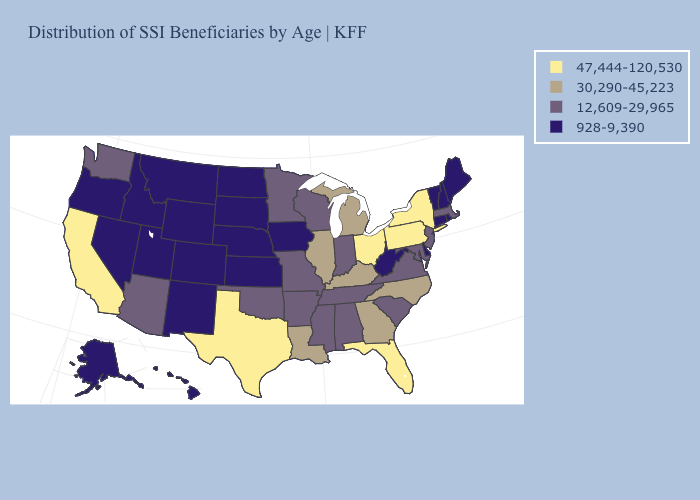What is the value of Arizona?
Keep it brief. 12,609-29,965. How many symbols are there in the legend?
Write a very short answer. 4. Which states have the lowest value in the West?
Give a very brief answer. Alaska, Colorado, Hawaii, Idaho, Montana, Nevada, New Mexico, Oregon, Utah, Wyoming. What is the lowest value in the MidWest?
Keep it brief. 928-9,390. Name the states that have a value in the range 12,609-29,965?
Answer briefly. Alabama, Arizona, Arkansas, Indiana, Maryland, Massachusetts, Minnesota, Mississippi, Missouri, New Jersey, Oklahoma, South Carolina, Tennessee, Virginia, Washington, Wisconsin. What is the highest value in the USA?
Keep it brief. 47,444-120,530. Among the states that border Iowa , does Nebraska have the highest value?
Quick response, please. No. Name the states that have a value in the range 12,609-29,965?
Give a very brief answer. Alabama, Arizona, Arkansas, Indiana, Maryland, Massachusetts, Minnesota, Mississippi, Missouri, New Jersey, Oklahoma, South Carolina, Tennessee, Virginia, Washington, Wisconsin. Is the legend a continuous bar?
Answer briefly. No. Is the legend a continuous bar?
Give a very brief answer. No. What is the lowest value in the West?
Answer briefly. 928-9,390. Name the states that have a value in the range 12,609-29,965?
Write a very short answer. Alabama, Arizona, Arkansas, Indiana, Maryland, Massachusetts, Minnesota, Mississippi, Missouri, New Jersey, Oklahoma, South Carolina, Tennessee, Virginia, Washington, Wisconsin. Name the states that have a value in the range 12,609-29,965?
Answer briefly. Alabama, Arizona, Arkansas, Indiana, Maryland, Massachusetts, Minnesota, Mississippi, Missouri, New Jersey, Oklahoma, South Carolina, Tennessee, Virginia, Washington, Wisconsin. What is the lowest value in the West?
Be succinct. 928-9,390. Does the first symbol in the legend represent the smallest category?
Give a very brief answer. No. 